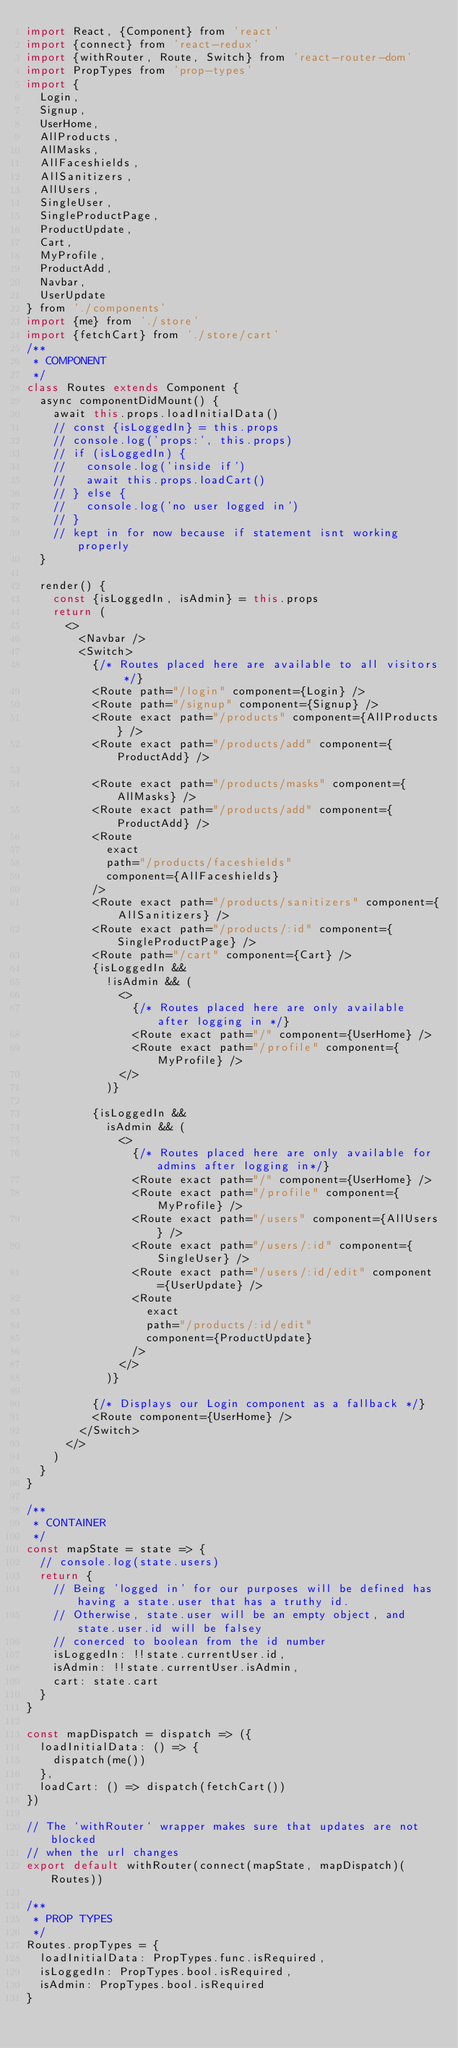<code> <loc_0><loc_0><loc_500><loc_500><_JavaScript_>import React, {Component} from 'react'
import {connect} from 'react-redux'
import {withRouter, Route, Switch} from 'react-router-dom'
import PropTypes from 'prop-types'
import {
  Login,
  Signup,
  UserHome,
  AllProducts,
  AllMasks,
  AllFaceshields,
  AllSanitizers,
  AllUsers,
  SingleUser,
  SingleProductPage,
  ProductUpdate,
  Cart,
  MyProfile,
  ProductAdd,
  Navbar,
  UserUpdate
} from './components'
import {me} from './store'
import {fetchCart} from './store/cart'
/**
 * COMPONENT
 */
class Routes extends Component {
  async componentDidMount() {
    await this.props.loadInitialData()
    // const {isLoggedIn} = this.props
    // console.log('props:', this.props)
    // if (isLoggedIn) {
    //   console.log('inside if')
    //   await this.props.loadCart()
    // } else {
    //   console.log('no user logged in')
    // }
    // kept in for now because if statement isnt working properly
  }

  render() {
    const {isLoggedIn, isAdmin} = this.props
    return (
      <>
        <Navbar />
        <Switch>
          {/* Routes placed here are available to all visitors */}
          <Route path="/login" component={Login} />
          <Route path="/signup" component={Signup} />
          <Route exact path="/products" component={AllProducts} />
          <Route exact path="/products/add" component={ProductAdd} />

          <Route exact path="/products/masks" component={AllMasks} />
          <Route exact path="/products/add" component={ProductAdd} />
          <Route
            exact
            path="/products/faceshields"
            component={AllFaceshields}
          />
          <Route exact path="/products/sanitizers" component={AllSanitizers} />
          <Route exact path="/products/:id" component={SingleProductPage} />
          <Route path="/cart" component={Cart} />
          {isLoggedIn &&
            !isAdmin && (
              <>
                {/* Routes placed here are only available after logging in */}
                <Route exact path="/" component={UserHome} />
                <Route exact path="/profile" component={MyProfile} />
              </>
            )}

          {isLoggedIn &&
            isAdmin && (
              <>
                {/* Routes placed here are only available for admins after logging in*/}
                <Route exact path="/" component={UserHome} />
                <Route exact path="/profile" component={MyProfile} />
                <Route exact path="/users" component={AllUsers} />
                <Route exact path="/users/:id" component={SingleUser} />
                <Route exact path="/users/:id/edit" component={UserUpdate} />
                <Route
                  exact
                  path="/products/:id/edit"
                  component={ProductUpdate}
                />
              </>
            )}

          {/* Displays our Login component as a fallback */}
          <Route component={UserHome} />
        </Switch>
      </>
    )
  }
}

/**
 * CONTAINER
 */
const mapState = state => {
  // console.log(state.users)
  return {
    // Being 'logged in' for our purposes will be defined has having a state.user that has a truthy id.
    // Otherwise, state.user will be an empty object, and state.user.id will be falsey
    // conerced to boolean from the id number
    isLoggedIn: !!state.currentUser.id,
    isAdmin: !!state.currentUser.isAdmin,
    cart: state.cart
  }
}

const mapDispatch = dispatch => ({
  loadInitialData: () => {
    dispatch(me())
  },
  loadCart: () => dispatch(fetchCart())
})

// The `withRouter` wrapper makes sure that updates are not blocked
// when the url changes
export default withRouter(connect(mapState, mapDispatch)(Routes))

/**
 * PROP TYPES
 */
Routes.propTypes = {
  loadInitialData: PropTypes.func.isRequired,
  isLoggedIn: PropTypes.bool.isRequired,
  isAdmin: PropTypes.bool.isRequired
}
</code> 